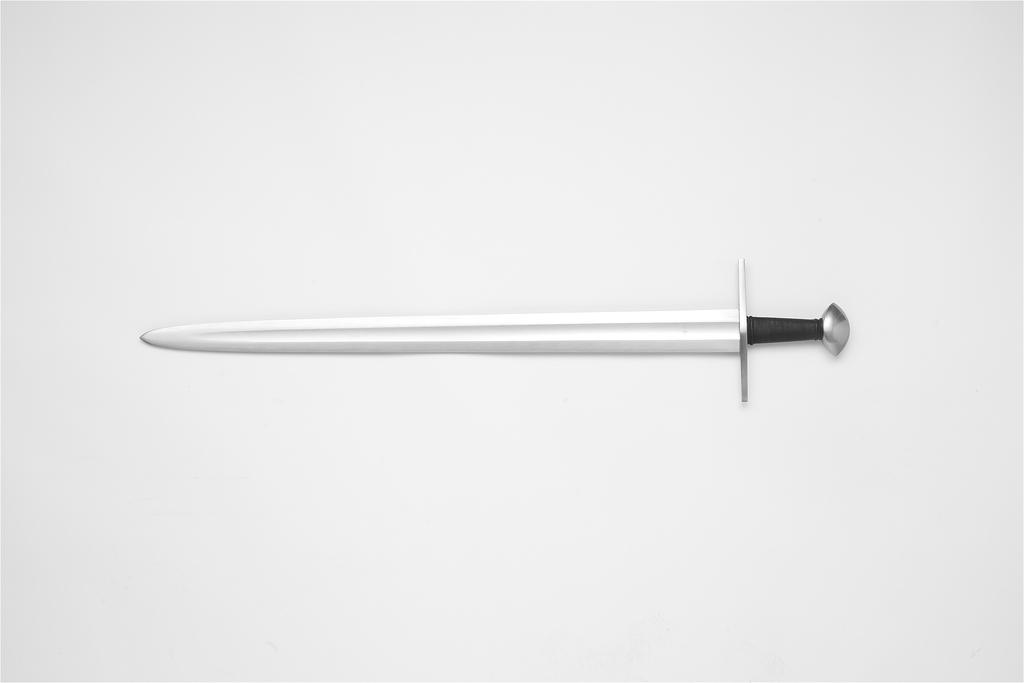What object is present in the image that is typically used as a weapon? There is a sword in the image. What color is the background of the image? The background of the image is white. How many ladybugs can be seen crawling on the sword in the image? There are no ladybugs present in the image. What type of apparatus is used to measure the length of the sword in the image? There is no apparatus present in the image to measure the length of the sword. How many steps are visible leading up to the sword in the image? There are no steps visible in the image. 